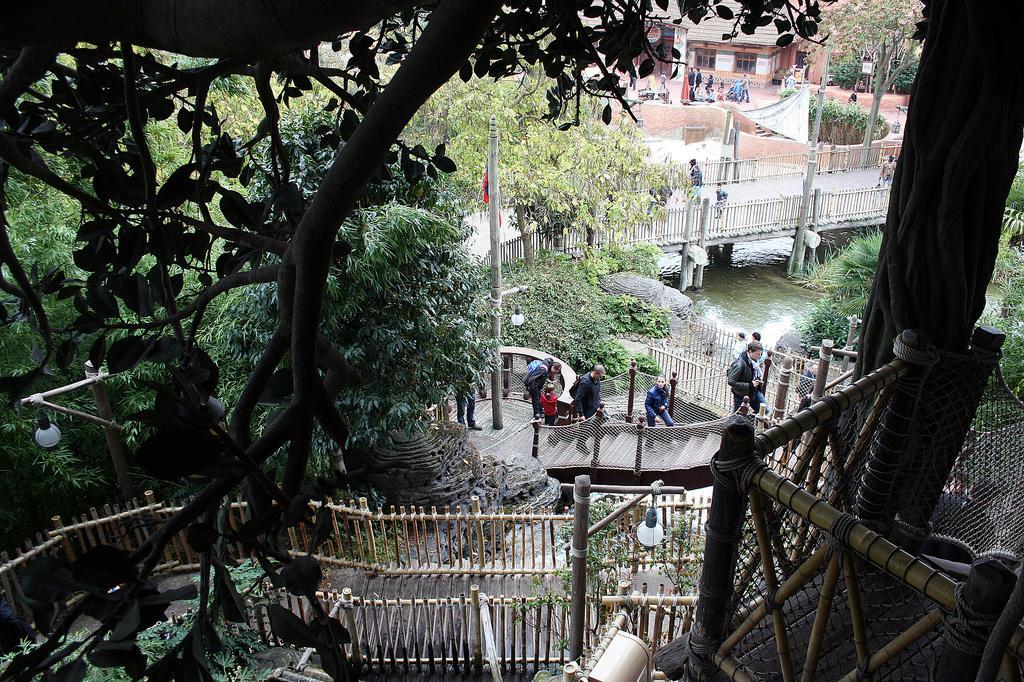Describe this image in one or two sentences. This picture contains a staircase and a railing. Here, we see people climbing up the staircase. On the left side, there are trees. In the right bottom of the picture, we see wooden rods or sticks. Behind that, we see trees. In the middle of the picture, we see a pole. Beside that, we see a bridge over the water. We see people are walking on the bridge. Beside that, we see a wooden railing. In the background, we see people walking on the road. There are trees and buildings in the background. 